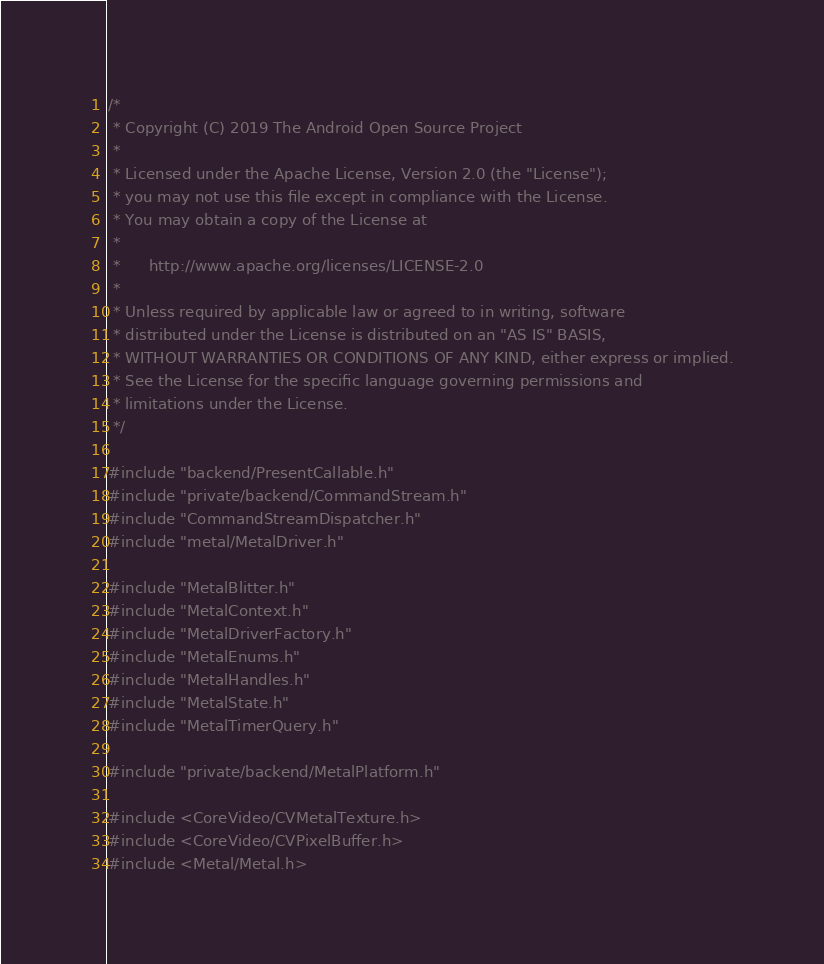<code> <loc_0><loc_0><loc_500><loc_500><_ObjectiveC_>/*
 * Copyright (C) 2019 The Android Open Source Project
 *
 * Licensed under the Apache License, Version 2.0 (the "License");
 * you may not use this file except in compliance with the License.
 * You may obtain a copy of the License at
 *
 *      http://www.apache.org/licenses/LICENSE-2.0
 *
 * Unless required by applicable law or agreed to in writing, software
 * distributed under the License is distributed on an "AS IS" BASIS,
 * WITHOUT WARRANTIES OR CONDITIONS OF ANY KIND, either express or implied.
 * See the License for the specific language governing permissions and
 * limitations under the License.
 */

#include "backend/PresentCallable.h"
#include "private/backend/CommandStream.h"
#include "CommandStreamDispatcher.h"
#include "metal/MetalDriver.h"

#include "MetalBlitter.h"
#include "MetalContext.h"
#include "MetalDriverFactory.h"
#include "MetalEnums.h"
#include "MetalHandles.h"
#include "MetalState.h"
#include "MetalTimerQuery.h"

#include "private/backend/MetalPlatform.h"

#include <CoreVideo/CVMetalTexture.h>
#include <CoreVideo/CVPixelBuffer.h>
#include <Metal/Metal.h></code> 